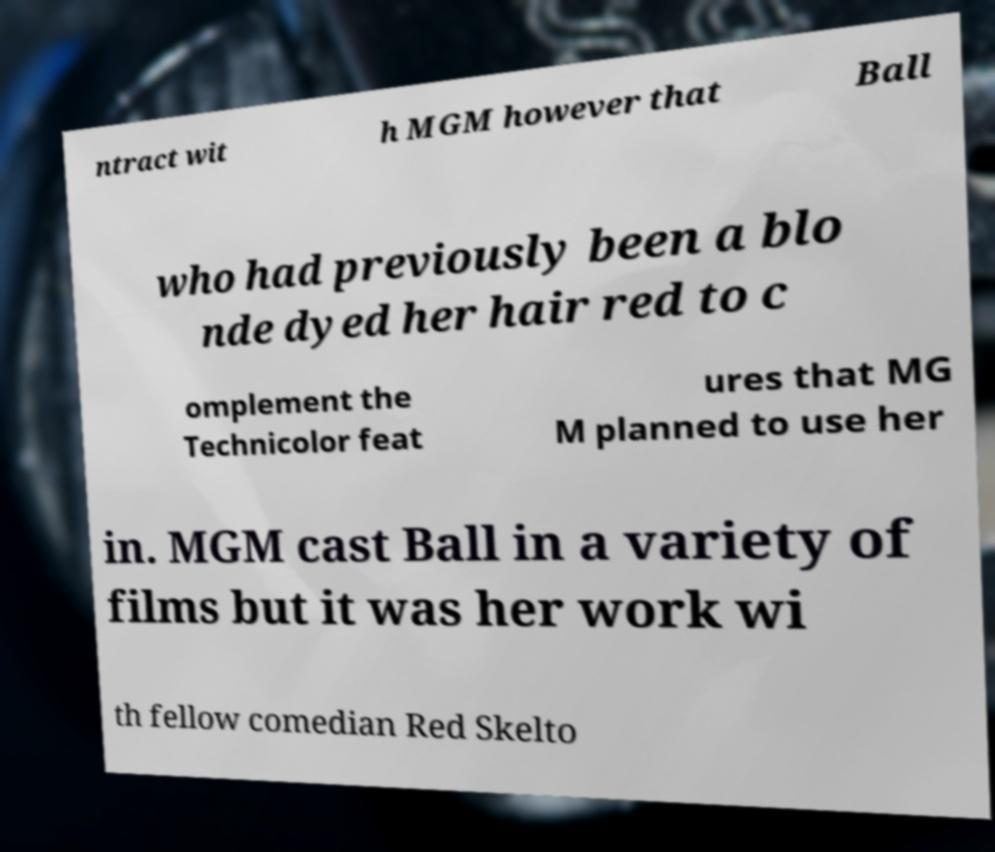There's text embedded in this image that I need extracted. Can you transcribe it verbatim? ntract wit h MGM however that Ball who had previously been a blo nde dyed her hair red to c omplement the Technicolor feat ures that MG M planned to use her in. MGM cast Ball in a variety of films but it was her work wi th fellow comedian Red Skelto 